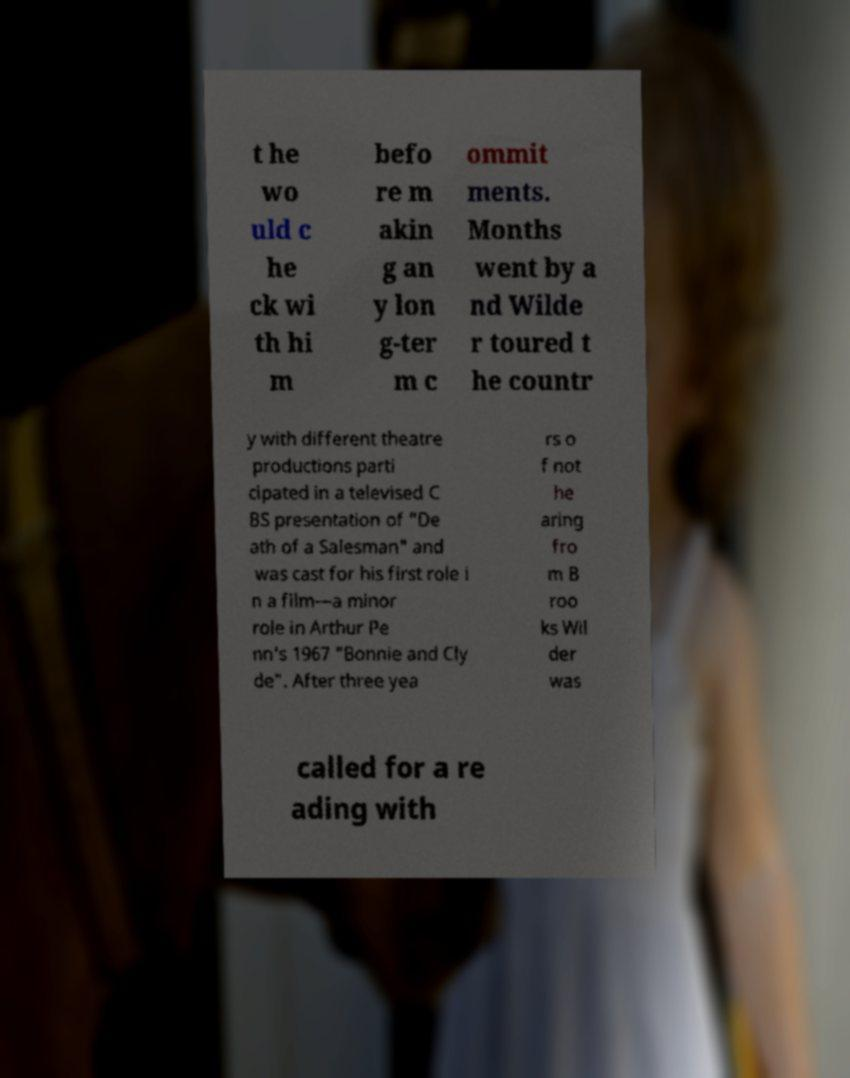Can you read and provide the text displayed in the image?This photo seems to have some interesting text. Can you extract and type it out for me? t he wo uld c he ck wi th hi m befo re m akin g an y lon g-ter m c ommit ments. Months went by a nd Wilde r toured t he countr y with different theatre productions parti cipated in a televised C BS presentation of "De ath of a Salesman" and was cast for his first role i n a film—a minor role in Arthur Pe nn's 1967 "Bonnie and Cly de". After three yea rs o f not he aring fro m B roo ks Wil der was called for a re ading with 